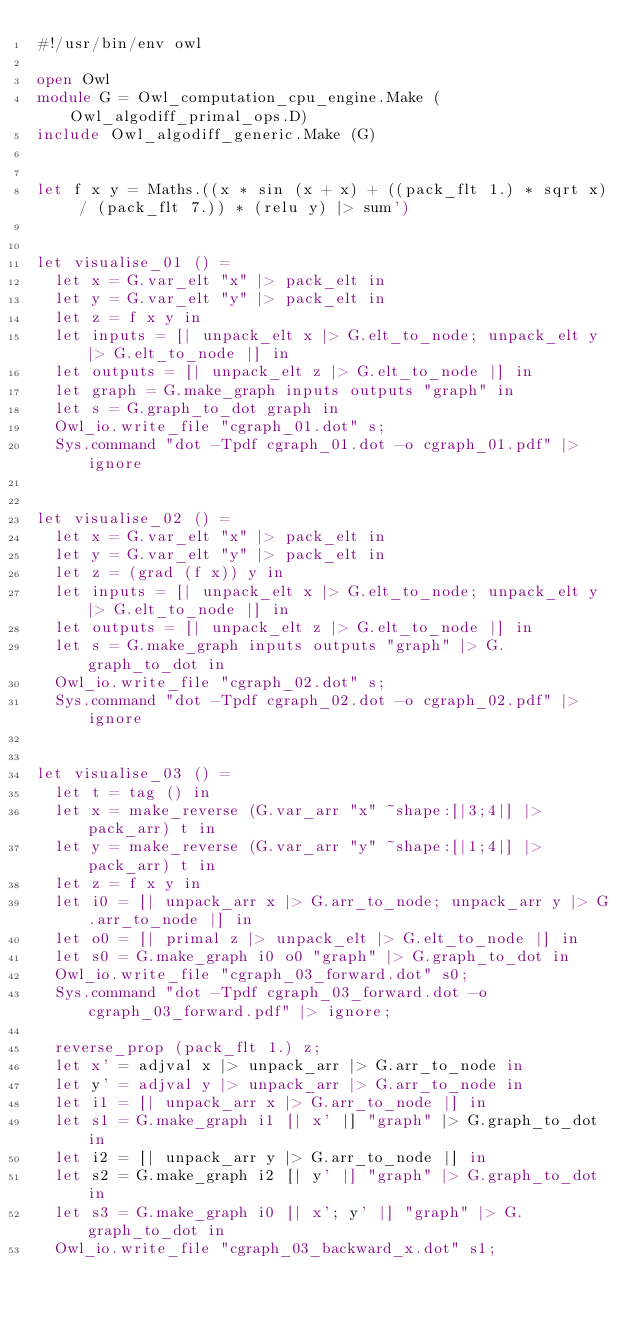Convert code to text. <code><loc_0><loc_0><loc_500><loc_500><_OCaml_>#!/usr/bin/env owl

open Owl
module G = Owl_computation_cpu_engine.Make (Owl_algodiff_primal_ops.D)
include Owl_algodiff_generic.Make (G)


let f x y = Maths.((x * sin (x + x) + ((pack_flt 1.) * sqrt x) / (pack_flt 7.)) * (relu y) |> sum')


let visualise_01 () =
  let x = G.var_elt "x" |> pack_elt in
  let y = G.var_elt "y" |> pack_elt in
  let z = f x y in
  let inputs = [| unpack_elt x |> G.elt_to_node; unpack_elt y |> G.elt_to_node |] in
  let outputs = [| unpack_elt z |> G.elt_to_node |] in
  let graph = G.make_graph inputs outputs "graph" in
  let s = G.graph_to_dot graph in
  Owl_io.write_file "cgraph_01.dot" s;
  Sys.command "dot -Tpdf cgraph_01.dot -o cgraph_01.pdf" |> ignore


let visualise_02 () =
  let x = G.var_elt "x" |> pack_elt in
  let y = G.var_elt "y" |> pack_elt in
  let z = (grad (f x)) y in
  let inputs = [| unpack_elt x |> G.elt_to_node; unpack_elt y |> G.elt_to_node |] in
  let outputs = [| unpack_elt z |> G.elt_to_node |] in
  let s = G.make_graph inputs outputs "graph" |> G.graph_to_dot in
  Owl_io.write_file "cgraph_02.dot" s;
  Sys.command "dot -Tpdf cgraph_02.dot -o cgraph_02.pdf" |> ignore


let visualise_03 () =
  let t = tag () in
  let x = make_reverse (G.var_arr "x" ~shape:[|3;4|] |> pack_arr) t in
  let y = make_reverse (G.var_arr "y" ~shape:[|1;4|] |> pack_arr) t in
  let z = f x y in
  let i0 = [| unpack_arr x |> G.arr_to_node; unpack_arr y |> G.arr_to_node |] in
  let o0 = [| primal z |> unpack_elt |> G.elt_to_node |] in
  let s0 = G.make_graph i0 o0 "graph" |> G.graph_to_dot in
  Owl_io.write_file "cgraph_03_forward.dot" s0;
  Sys.command "dot -Tpdf cgraph_03_forward.dot -o cgraph_03_forward.pdf" |> ignore;

  reverse_prop (pack_flt 1.) z;
  let x' = adjval x |> unpack_arr |> G.arr_to_node in
  let y' = adjval y |> unpack_arr |> G.arr_to_node in
  let i1 = [| unpack_arr x |> G.arr_to_node |] in
  let s1 = G.make_graph i1 [| x' |] "graph" |> G.graph_to_dot in
  let i2 = [| unpack_arr y |> G.arr_to_node |] in
  let s2 = G.make_graph i2 [| y' |] "graph" |> G.graph_to_dot in
  let s3 = G.make_graph i0 [| x'; y' |] "graph" |> G.graph_to_dot in
  Owl_io.write_file "cgraph_03_backward_x.dot" s1;</code> 